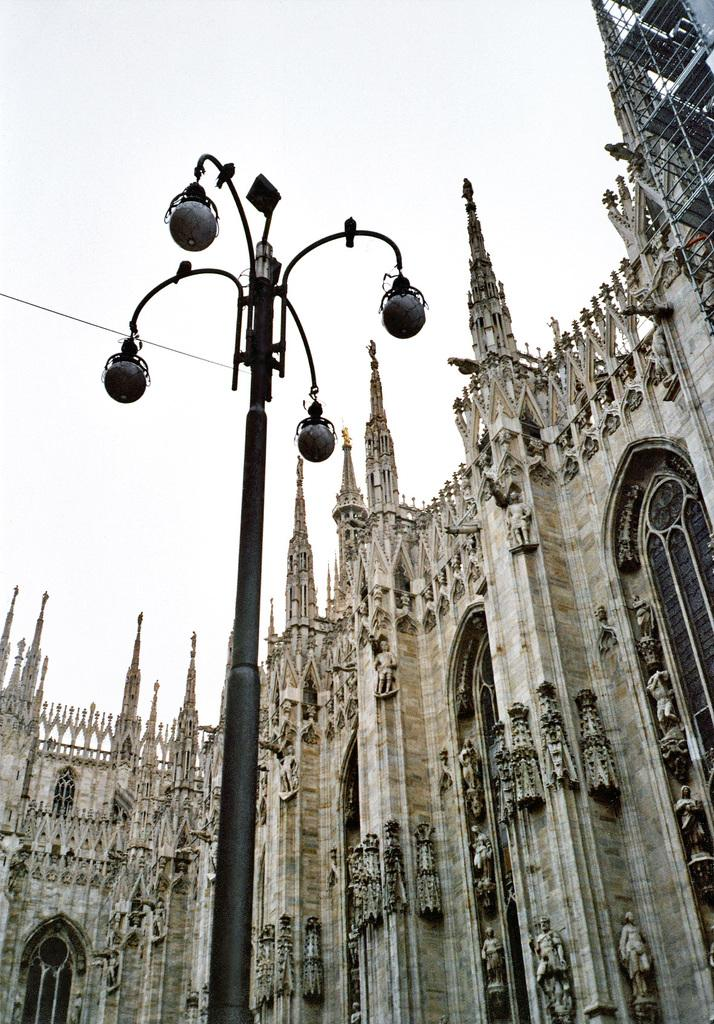What is on the pole that is visible in the image? There are lights on a pole in the image. What can be seen in the background of the image? There is a building and the sky visible in the background of the image. What type of treatment is the toad receiving in the image? There is no toad present in the image, so it is not possible to determine what type of treatment it might be receiving. 